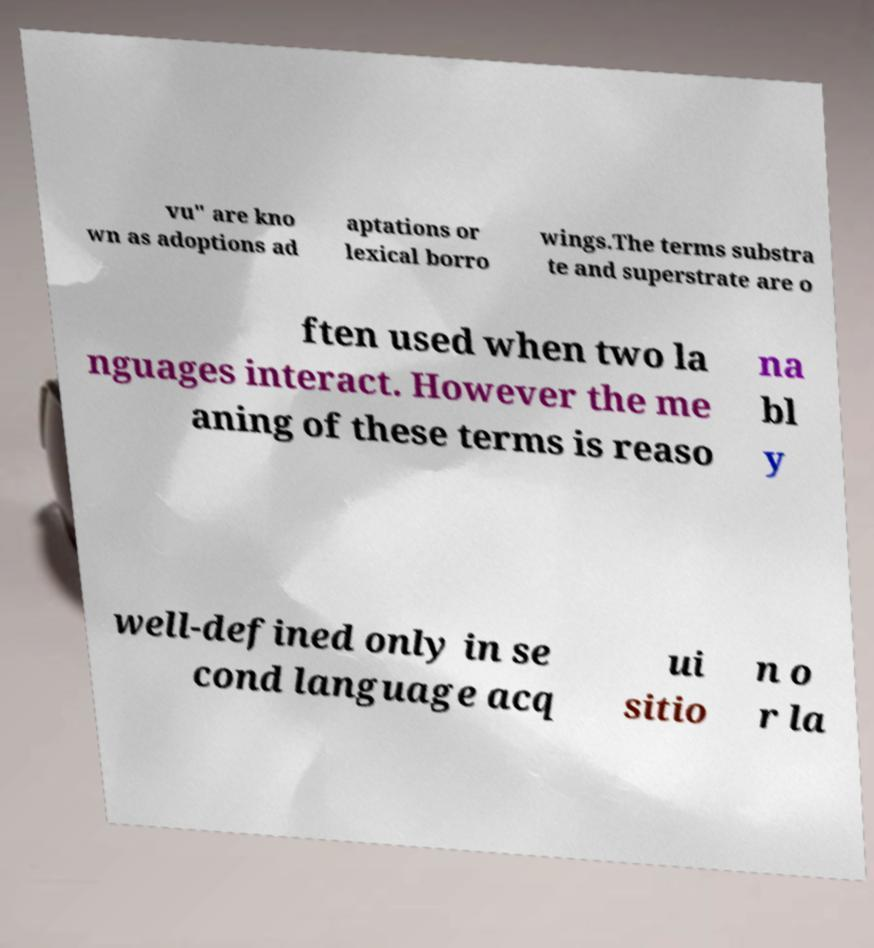Please read and relay the text visible in this image. What does it say? vu" are kno wn as adoptions ad aptations or lexical borro wings.The terms substra te and superstrate are o ften used when two la nguages interact. However the me aning of these terms is reaso na bl y well-defined only in se cond language acq ui sitio n o r la 